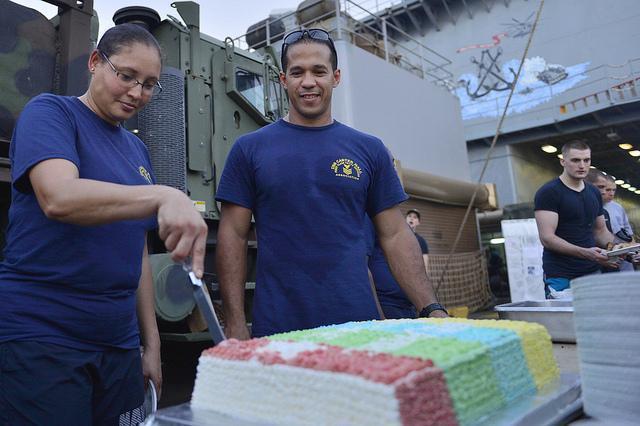Is the statement "The truck is part of the cake." accurate regarding the image?
Answer yes or no. No. Does the caption "The cake is in front of the truck." correctly depict the image?
Answer yes or no. Yes. 